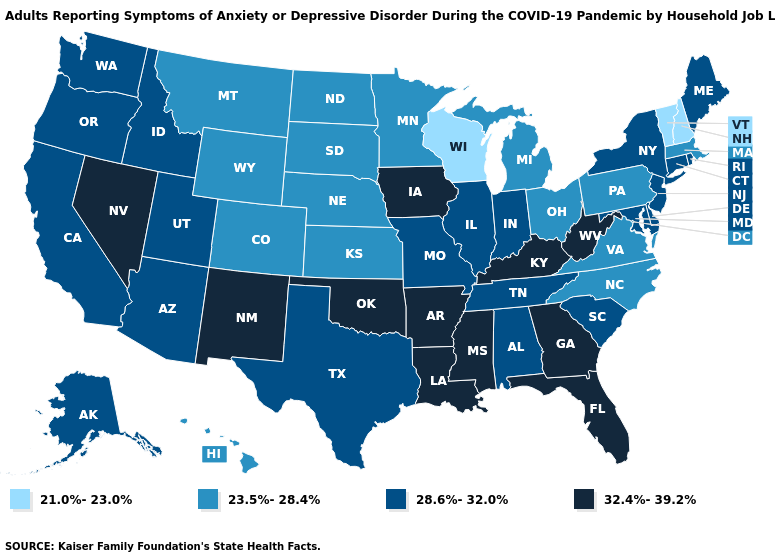Name the states that have a value in the range 32.4%-39.2%?
Answer briefly. Arkansas, Florida, Georgia, Iowa, Kentucky, Louisiana, Mississippi, Nevada, New Mexico, Oklahoma, West Virginia. Does the first symbol in the legend represent the smallest category?
Keep it brief. Yes. What is the value of Wyoming?
Write a very short answer. 23.5%-28.4%. Does Wisconsin have the lowest value in the USA?
Answer briefly. Yes. Is the legend a continuous bar?
Be succinct. No. Name the states that have a value in the range 32.4%-39.2%?
Quick response, please. Arkansas, Florida, Georgia, Iowa, Kentucky, Louisiana, Mississippi, Nevada, New Mexico, Oklahoma, West Virginia. Name the states that have a value in the range 32.4%-39.2%?
Write a very short answer. Arkansas, Florida, Georgia, Iowa, Kentucky, Louisiana, Mississippi, Nevada, New Mexico, Oklahoma, West Virginia. Name the states that have a value in the range 21.0%-23.0%?
Short answer required. New Hampshire, Vermont, Wisconsin. What is the highest value in the USA?
Quick response, please. 32.4%-39.2%. Does Wisconsin have the lowest value in the MidWest?
Quick response, please. Yes. Does Nevada have the lowest value in the USA?
Be succinct. No. Name the states that have a value in the range 28.6%-32.0%?
Give a very brief answer. Alabama, Alaska, Arizona, California, Connecticut, Delaware, Idaho, Illinois, Indiana, Maine, Maryland, Missouri, New Jersey, New York, Oregon, Rhode Island, South Carolina, Tennessee, Texas, Utah, Washington. Does the first symbol in the legend represent the smallest category?
Be succinct. Yes. Which states have the lowest value in the USA?
Be succinct. New Hampshire, Vermont, Wisconsin. Does Virginia have the lowest value in the South?
Give a very brief answer. Yes. 